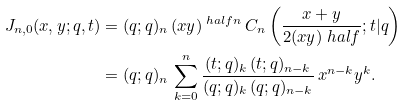<formula> <loc_0><loc_0><loc_500><loc_500>J _ { n , 0 } ( x , y ; q , t ) & = ( q ; q ) _ { n } \, ( x y ) ^ { \ h a l f n } \, C _ { n } \left ( \frac { x + y } { 2 ( x y ) ^ { \ } h a l f } ; t | q \right ) \\ & = ( q ; q ) _ { n } \, \sum _ { k = 0 } ^ { n } \frac { ( t ; q ) _ { k } \, ( t ; q ) _ { n - k } } { ( q ; q ) _ { k } \, ( q ; q ) _ { n - k } } \, x ^ { n - k } y ^ { k } .</formula> 